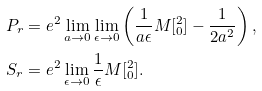Convert formula to latex. <formula><loc_0><loc_0><loc_500><loc_500>P _ { r } & = e ^ { 2 } \lim _ { a \rightarrow 0 } \lim _ { \epsilon \rightarrow 0 } \left ( \frac { 1 } { a \epsilon } M [ ^ { 2 } _ { 0 } ] - \frac { 1 } { 2 a ^ { 2 } } \right ) , \\ S _ { r } & = e ^ { 2 } \lim _ { \epsilon \rightarrow 0 } \frac { 1 } { \epsilon } M [ ^ { 2 } _ { 0 } ] .</formula> 